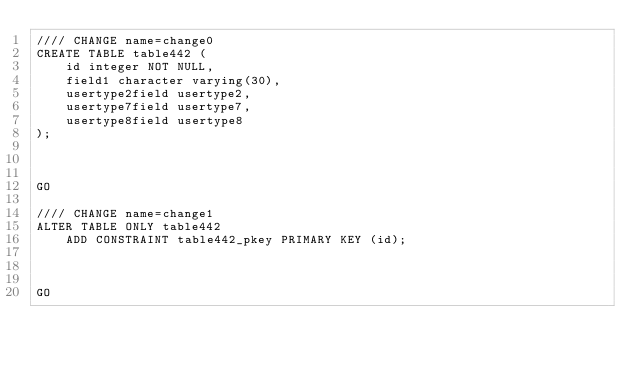Convert code to text. <code><loc_0><loc_0><loc_500><loc_500><_SQL_>//// CHANGE name=change0
CREATE TABLE table442 (
    id integer NOT NULL,
    field1 character varying(30),
    usertype2field usertype2,
    usertype7field usertype7,
    usertype8field usertype8
);



GO

//// CHANGE name=change1
ALTER TABLE ONLY table442
    ADD CONSTRAINT table442_pkey PRIMARY KEY (id);



GO
</code> 